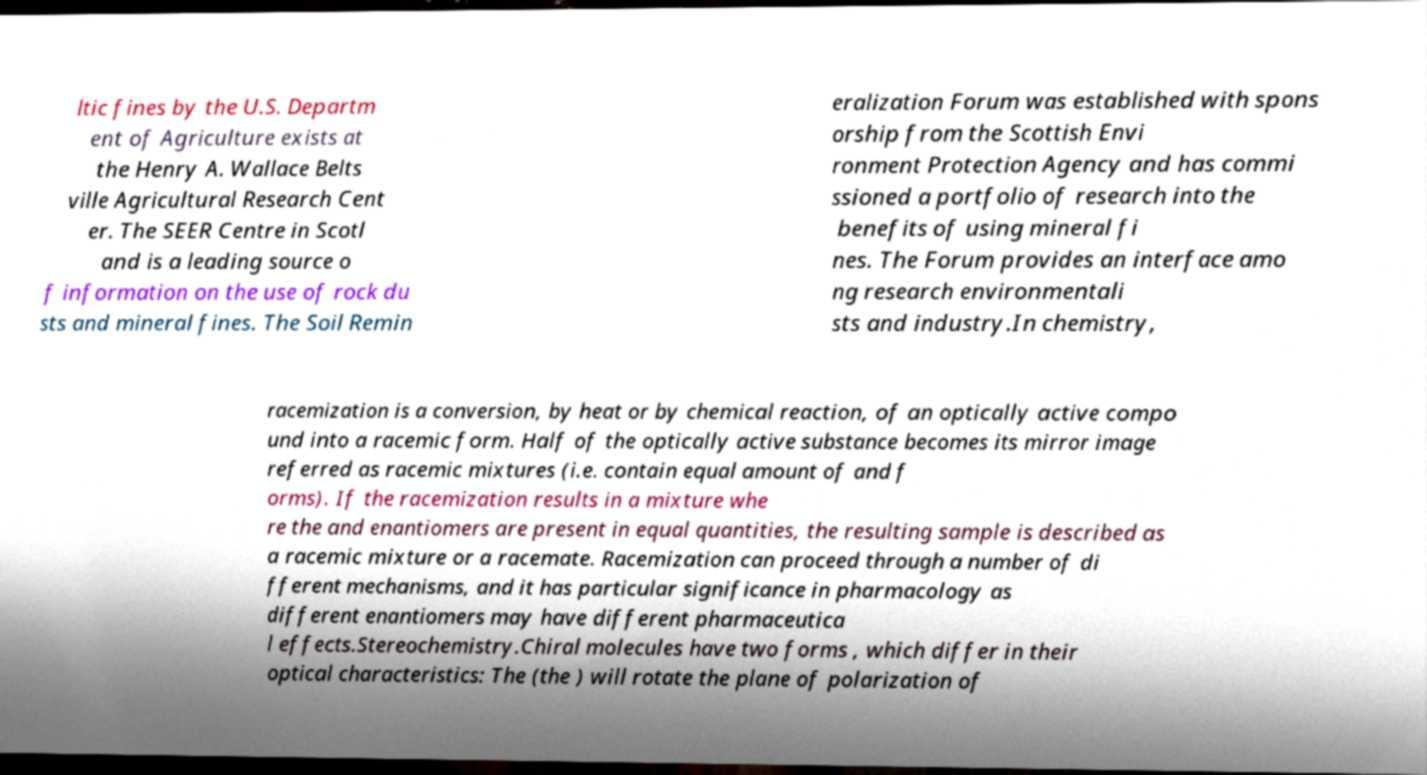For documentation purposes, I need the text within this image transcribed. Could you provide that? ltic fines by the U.S. Departm ent of Agriculture exists at the Henry A. Wallace Belts ville Agricultural Research Cent er. The SEER Centre in Scotl and is a leading source o f information on the use of rock du sts and mineral fines. The Soil Remin eralization Forum was established with spons orship from the Scottish Envi ronment Protection Agency and has commi ssioned a portfolio of research into the benefits of using mineral fi nes. The Forum provides an interface amo ng research environmentali sts and industry.In chemistry, racemization is a conversion, by heat or by chemical reaction, of an optically active compo und into a racemic form. Half of the optically active substance becomes its mirror image referred as racemic mixtures (i.e. contain equal amount of and f orms). If the racemization results in a mixture whe re the and enantiomers are present in equal quantities, the resulting sample is described as a racemic mixture or a racemate. Racemization can proceed through a number of di fferent mechanisms, and it has particular significance in pharmacology as different enantiomers may have different pharmaceutica l effects.Stereochemistry.Chiral molecules have two forms , which differ in their optical characteristics: The (the ) will rotate the plane of polarization of 